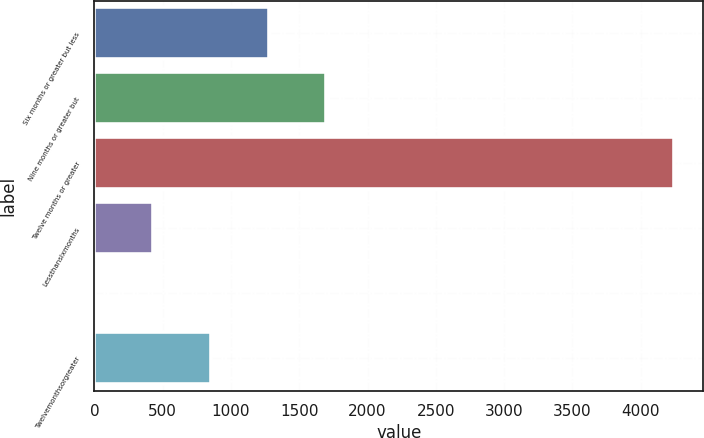<chart> <loc_0><loc_0><loc_500><loc_500><bar_chart><fcel>Six months or greater but less<fcel>Nine months or greater but<fcel>Twelve months or greater<fcel>Lessthansixmonths<fcel>Unnamed: 4<fcel>Twelvemonthsorgreater<nl><fcel>1274.8<fcel>1699.4<fcel>4247<fcel>425.6<fcel>1<fcel>850.2<nl></chart> 